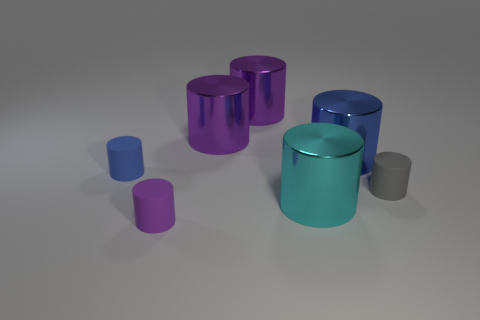How many things are either matte cylinders that are to the left of the gray cylinder or cylinders behind the tiny purple rubber object?
Your response must be concise. 7. Are there the same number of large cyan metal cylinders behind the blue rubber cylinder and big cyan shiny things behind the large blue cylinder?
Your answer should be compact. Yes. What shape is the blue thing that is on the right side of the small matte thing that is in front of the gray matte object?
Ensure brevity in your answer.  Cylinder. Are there any cyan metal objects of the same shape as the tiny gray thing?
Provide a short and direct response. Yes. What number of small green rubber cylinders are there?
Provide a short and direct response. 0. Does the tiny cylinder right of the big cyan metallic thing have the same material as the cyan thing?
Offer a very short reply. No. Is there another cyan object of the same size as the cyan metal thing?
Your response must be concise. No. There is a tiny purple rubber object; is its shape the same as the small matte thing left of the tiny purple matte cylinder?
Make the answer very short. Yes. There is a small object that is right of the tiny object that is in front of the big cyan shiny thing; are there any large cyan things in front of it?
Offer a very short reply. Yes. How big is the gray matte object?
Make the answer very short. Small. 